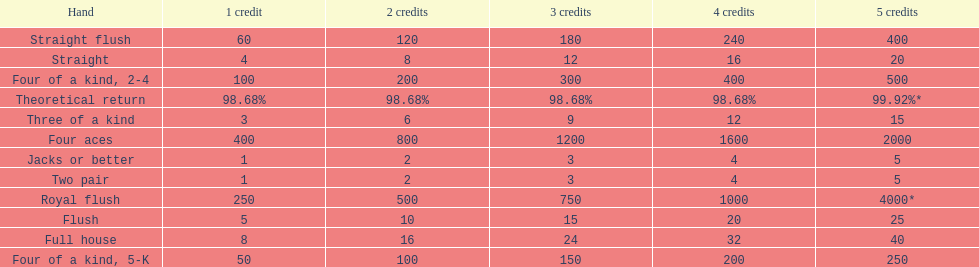Could you parse the entire table? {'header': ['Hand', '1 credit', '2 credits', '3 credits', '4 credits', '5 credits'], 'rows': [['Straight flush', '60', '120', '180', '240', '400'], ['Straight', '4', '8', '12', '16', '20'], ['Four of a kind, 2-4', '100', '200', '300', '400', '500'], ['Theoretical return', '98.68%', '98.68%', '98.68%', '98.68%', '99.92%*'], ['Three of a kind', '3', '6', '9', '12', '15'], ['Four aces', '400', '800', '1200', '1600', '2000'], ['Jacks or better', '1', '2', '3', '4', '5'], ['Two pair', '1', '2', '3', '4', '5'], ['Royal flush', '250', '500', '750', '1000', '4000*'], ['Flush', '5', '10', '15', '20', '25'], ['Full house', '8', '16', '24', '32', '40'], ['Four of a kind, 5-K', '50', '100', '150', '200', '250']]} What is the total amount of a 3 credit straight flush? 180. 